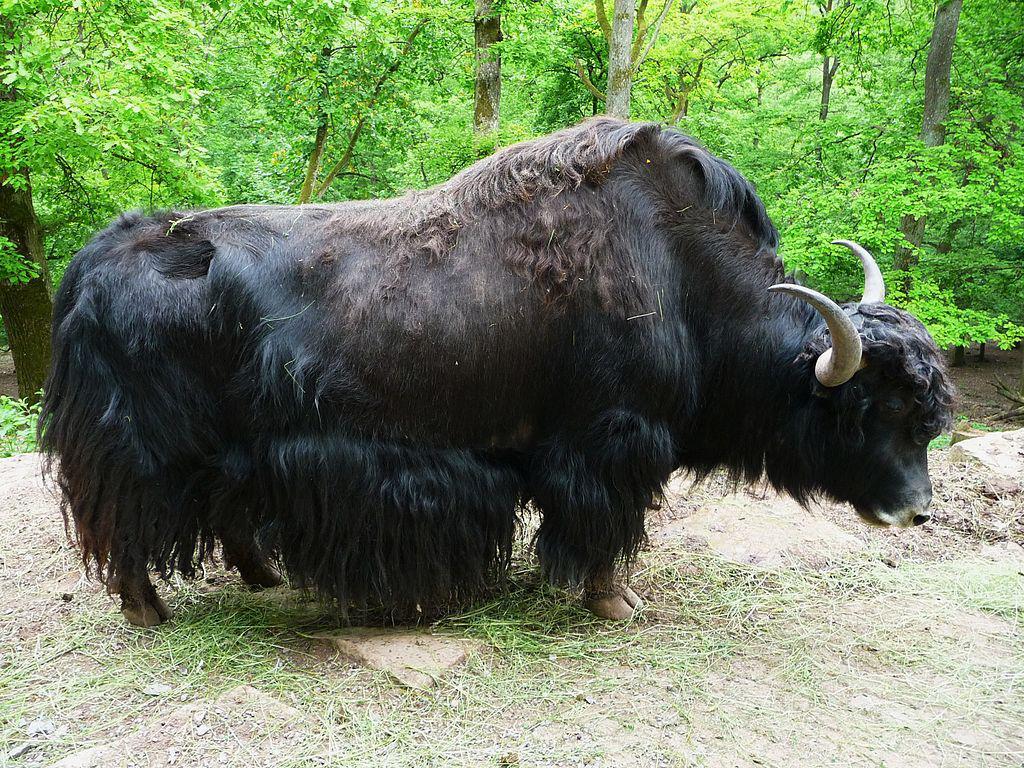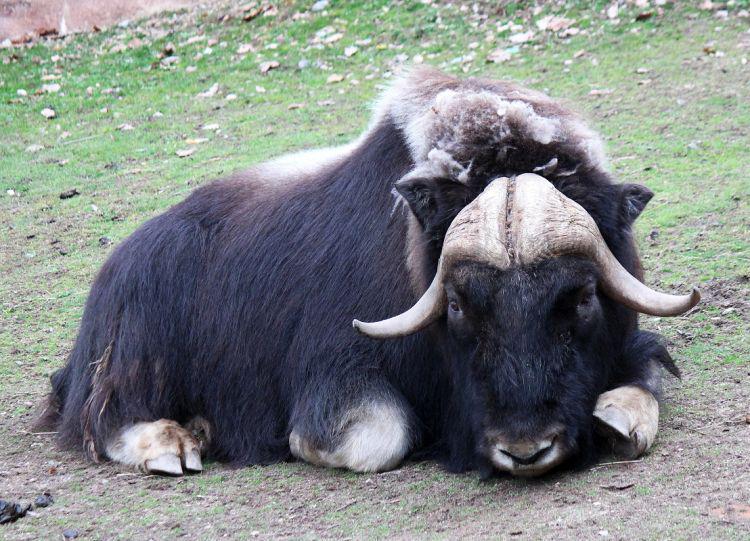The first image is the image on the left, the second image is the image on the right. For the images displayed, is the sentence "There are trees in the background of the image on the left." factually correct? Answer yes or no. Yes. 